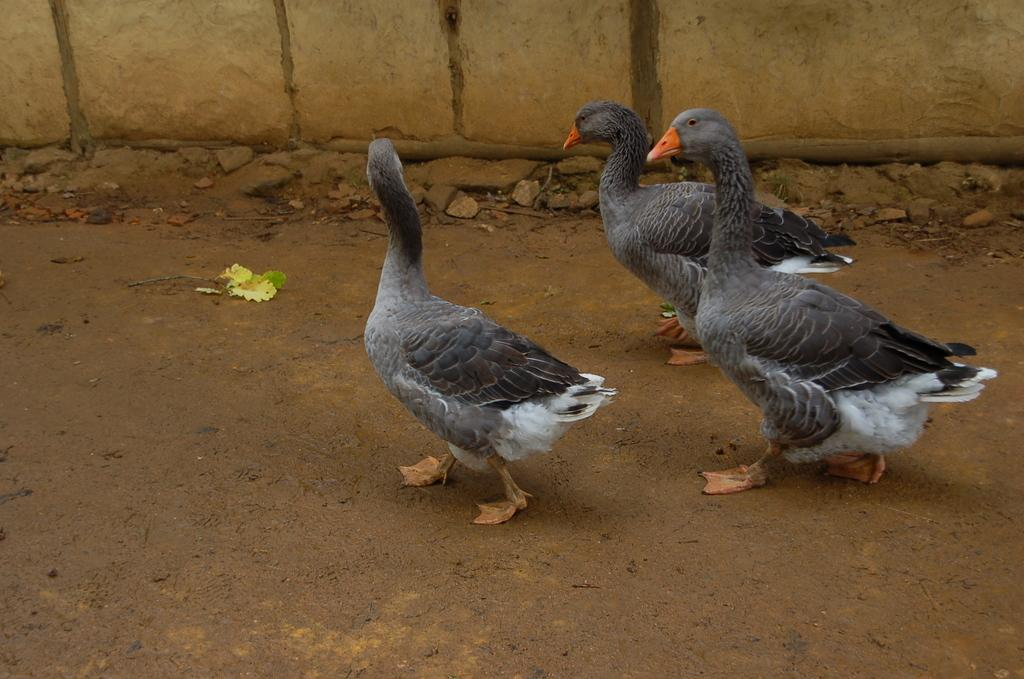How many ducks are present in the image? There are three ducks in the image. What are the ducks doing in the image? The ducks are walking on the road. Can you describe the appearance of the ducks? The ducks are in grey and white color with orange peaks. What can be seen in the background of the image? There is a yellow wall in the background of the image. What type of juice is being served at the duck's birthday party in the image? There is no mention of a birthday party or juice in the image; it simply shows three ducks walking on the road. 